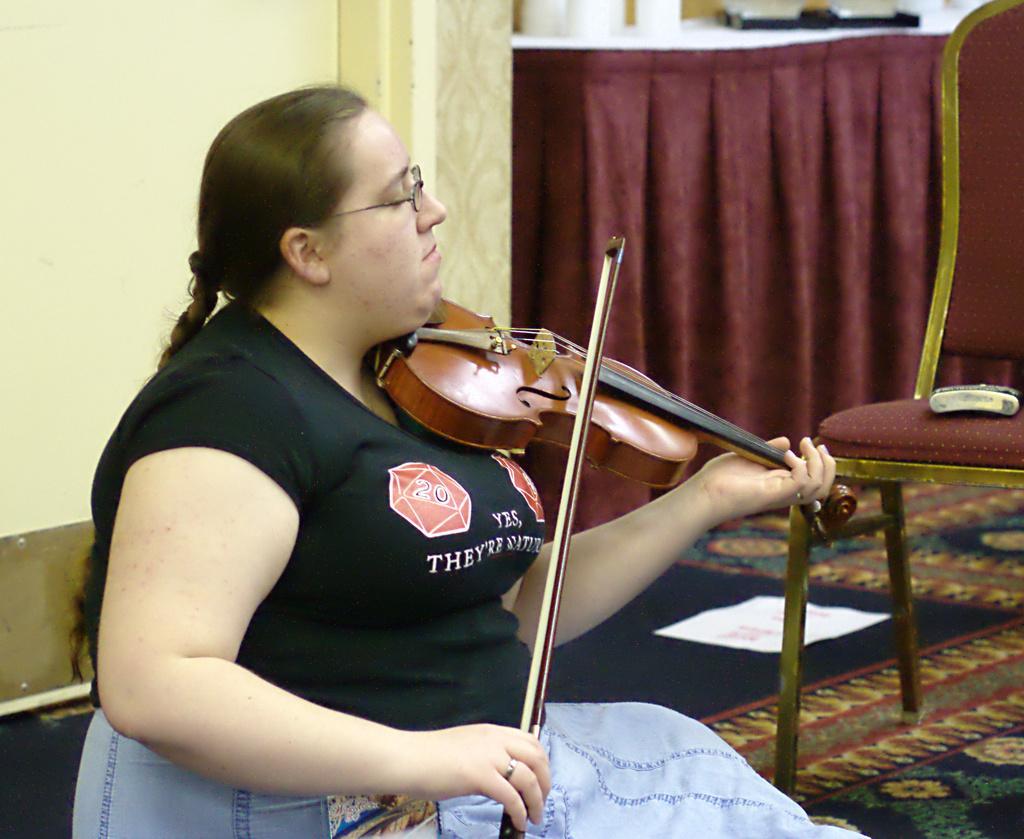Please provide a concise description of this image. In this image I can see a woman playing the violin and she is wearing the black color t-shirt. To the right there is a chair and a curtain can be seen and they are in maroon color. I can also see a carpet on the floor. 